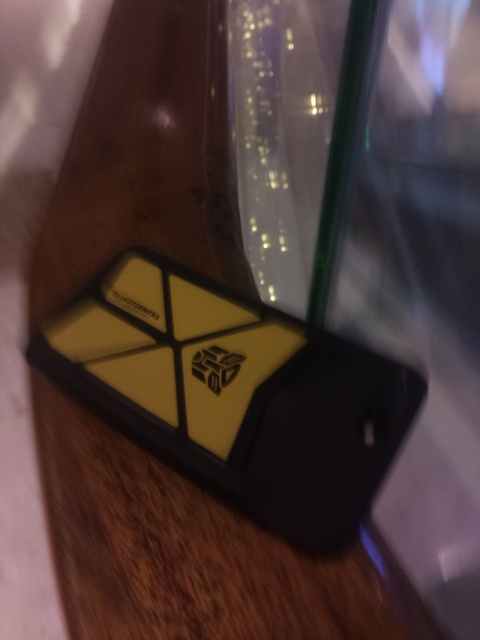Can you tell me the type of phone in the picture? Given the visible design and case, it appears to be a smartphone, but due to the image's poor quality, the exact model cannot be determined. 